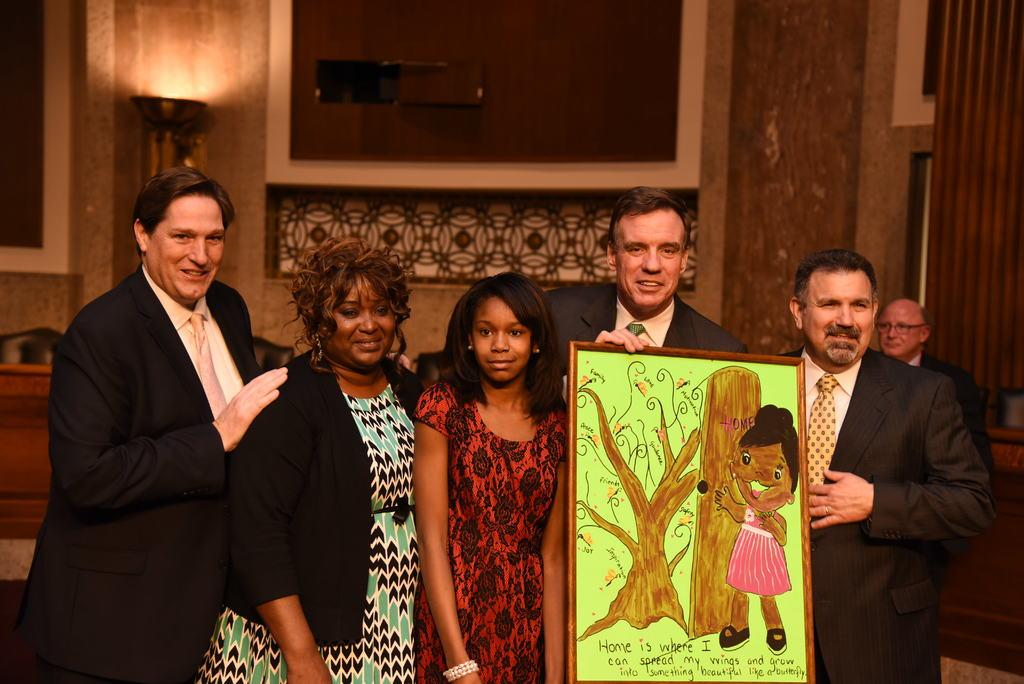What are the people in the image doing? The persons standing on the ground in the image are holding a painting. What can be seen in the background of the image? There are walls and a bowl with fire visible in the background of the image. Can you see any veins in the painting that the person is holding? There is no information about the content of the painting, so it is impossible to determine if veins are visible in the image. Is there a river flowing near the persons in the image? There is no mention of a river in the provided facts, so it cannot be determined if a river is present in the image. 